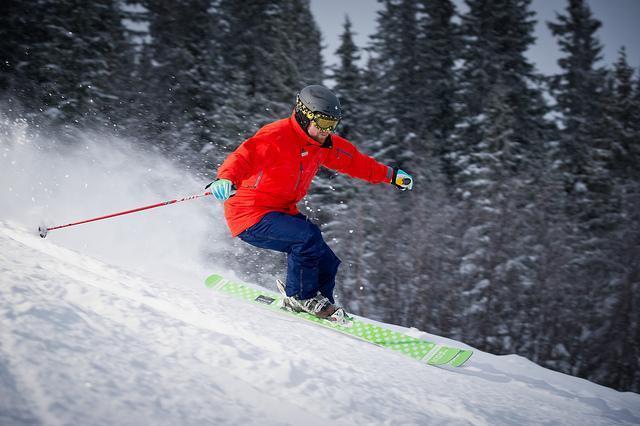How many horses in this race?
Give a very brief answer. 0. 